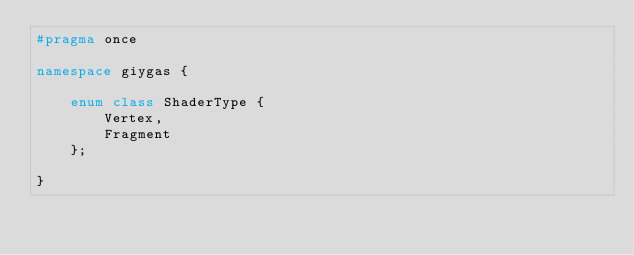Convert code to text. <code><loc_0><loc_0><loc_500><loc_500><_C++_>#pragma once

namespace giygas {

    enum class ShaderType {
        Vertex,
        Fragment
    };

}</code> 